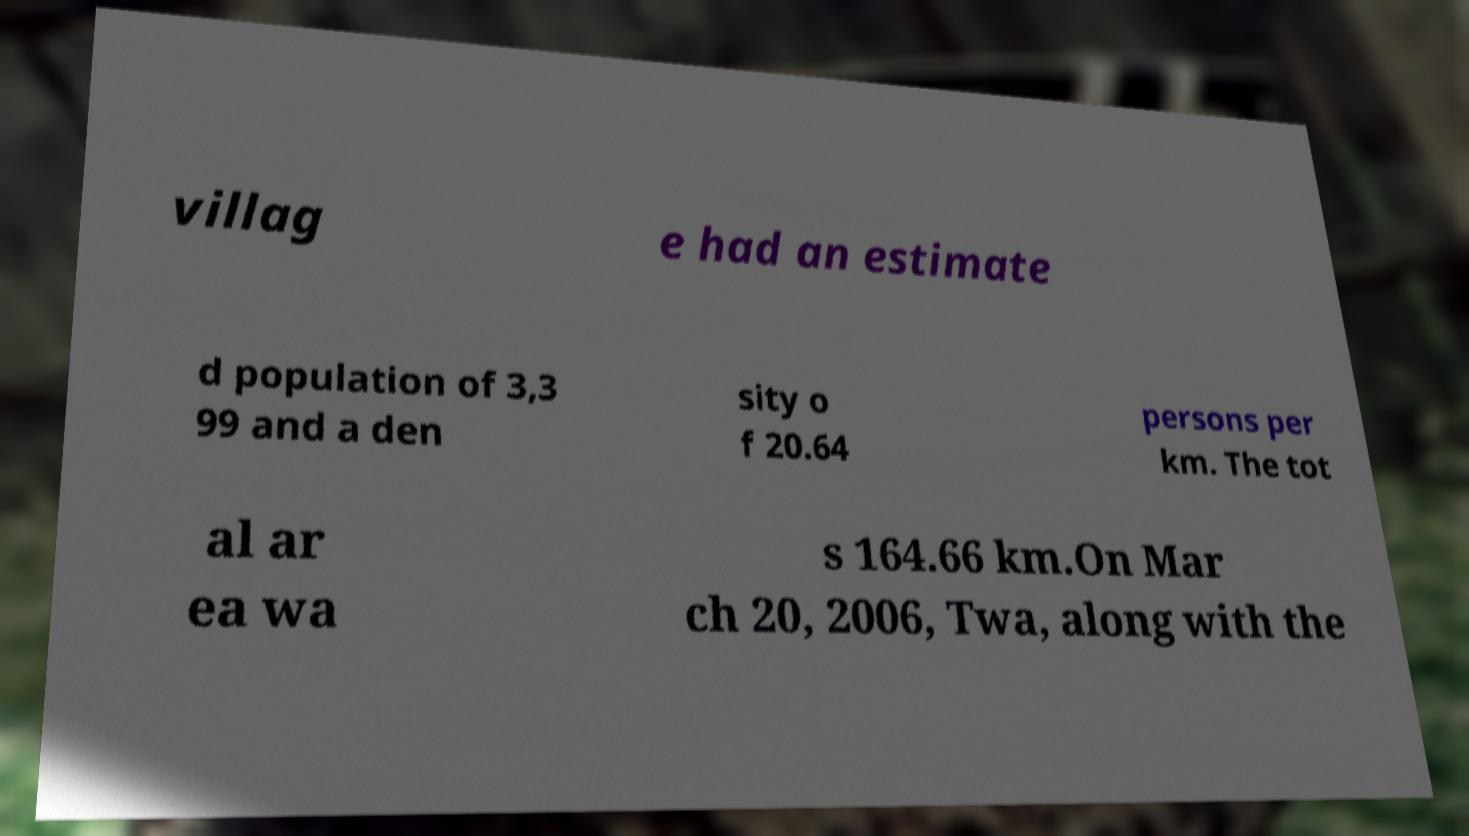There's text embedded in this image that I need extracted. Can you transcribe it verbatim? villag e had an estimate d population of 3,3 99 and a den sity o f 20.64 persons per km. The tot al ar ea wa s 164.66 km.On Mar ch 20, 2006, Twa, along with the 